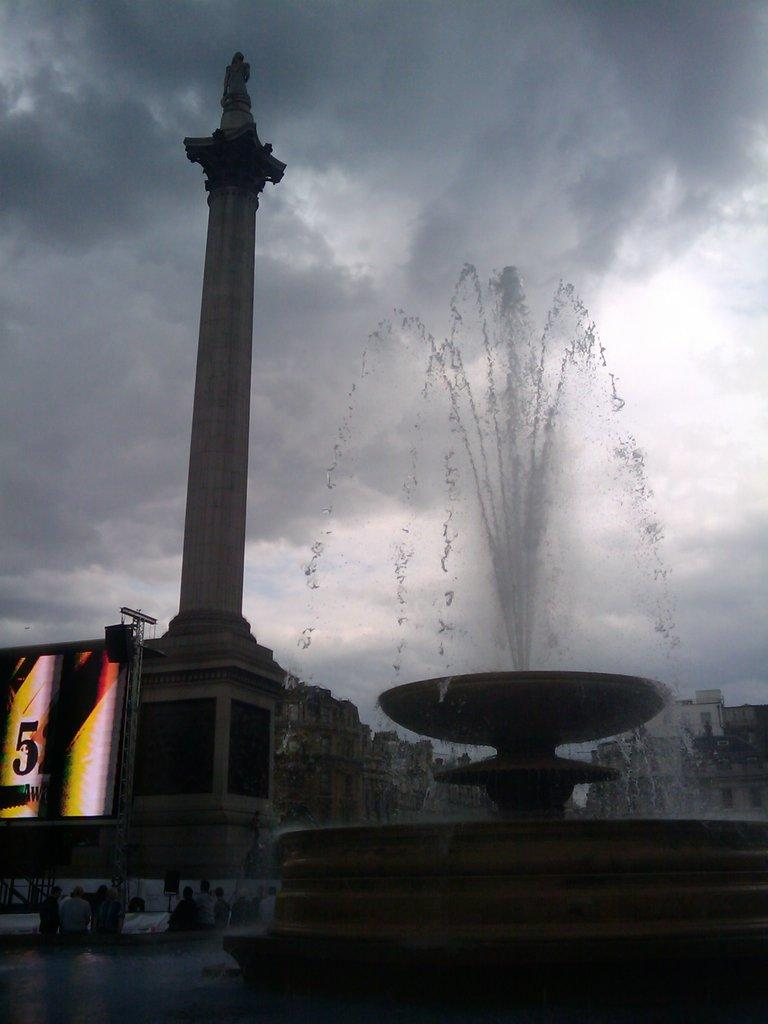<image>
Provide a brief description of the given image. A lit sign with the number 52 is set up next to a pillar and a fountain. 